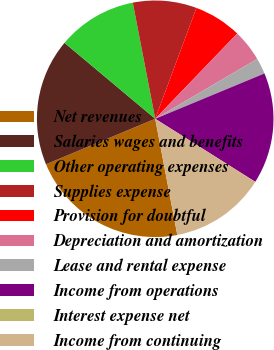<chart> <loc_0><loc_0><loc_500><loc_500><pie_chart><fcel>Net revenues<fcel>Salaries wages and benefits<fcel>Other operating expenses<fcel>Supplies expense<fcel>Provision for doubtful<fcel>Depreciation and amortization<fcel>Lease and rental expense<fcel>Income from operations<fcel>Interest expense net<fcel>Income from continuing<nl><fcel>21.71%<fcel>17.38%<fcel>10.87%<fcel>8.7%<fcel>6.53%<fcel>4.36%<fcel>2.19%<fcel>15.21%<fcel>0.02%<fcel>13.04%<nl></chart> 